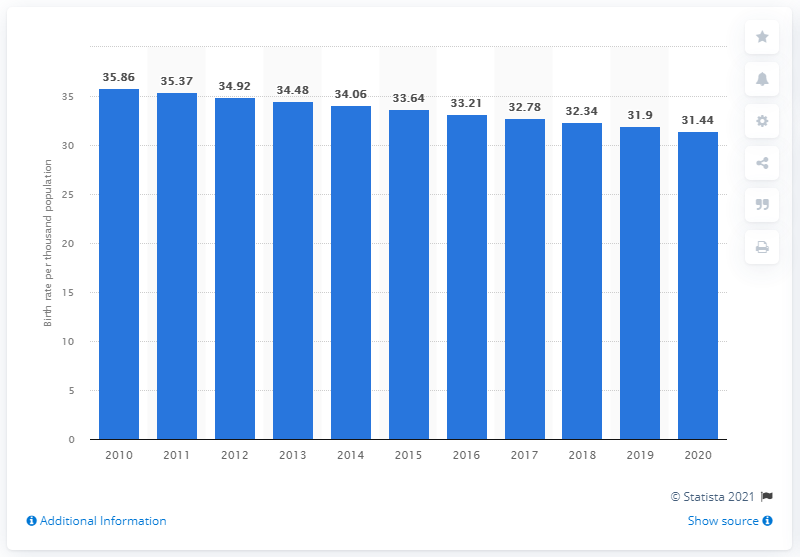Indicate a few pertinent items in this graphic. According to data from 2020, the crude birth rate in Ethiopia was 31.44. 